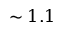<formula> <loc_0><loc_0><loc_500><loc_500>\sim 1 . 1</formula> 